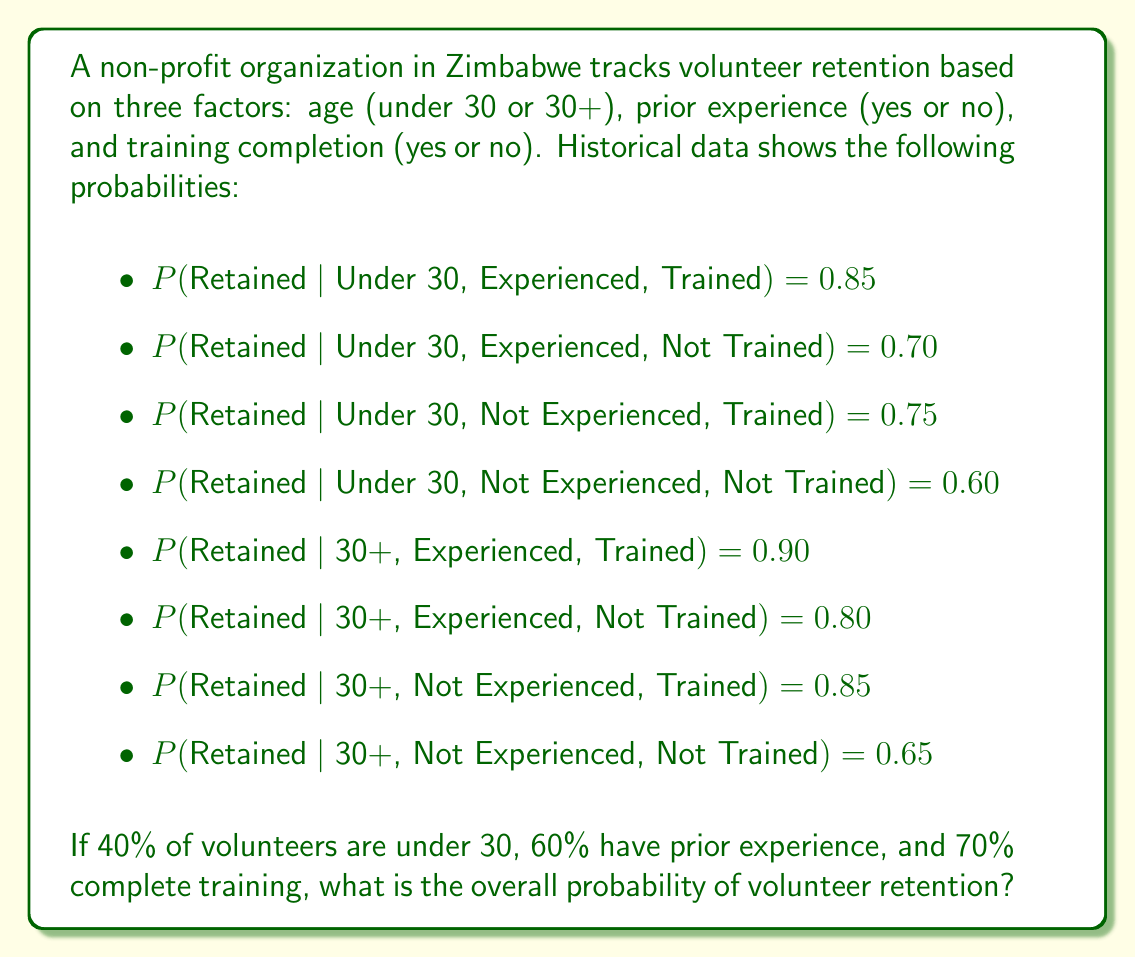Show me your answer to this math problem. To solve this problem, we'll use the law of total probability. We need to consider all possible combinations of the three factors and their respective probabilities.

Let's define events:
A: Under 30, B: Experienced, C: Trained

Step 1: List all possible combinations and their probabilities
P(A) = 0.40, P(Not A) = 0.60
P(B) = 0.60, P(Not B) = 0.40
P(C) = 0.70, P(Not C) = 0.30

Step 2: Calculate the probability of each combination
P(A,B,C) = 0.40 * 0.60 * 0.70 = 0.168
P(A,B,Not C) = 0.40 * 0.60 * 0.30 = 0.072
P(A,Not B,C) = 0.40 * 0.40 * 0.70 = 0.112
P(A,Not B,Not C) = 0.40 * 0.40 * 0.30 = 0.048
P(Not A,B,C) = 0.60 * 0.60 * 0.70 = 0.252
P(Not A,B,Not C) = 0.60 * 0.60 * 0.30 = 0.108
P(Not A,Not B,C) = 0.60 * 0.40 * 0.70 = 0.168
P(Not A,Not B,Not C) = 0.60 * 0.40 * 0.30 = 0.072

Step 3: Apply the law of total probability
$$P(\text{Retained}) = \sum_{i=1}^{8} P(\text{Retained}|\text{Combination}_i) \cdot P(\text{Combination}_i)$$

$$P(\text{Retained}) = 0.85 \cdot 0.168 + 0.70 \cdot 0.072 + 0.75 \cdot 0.112 + 0.60 \cdot 0.048 + $$
$$0.90 \cdot 0.252 + 0.80 \cdot 0.108 + 0.85 \cdot 0.168 + 0.65 \cdot 0.072$$

Step 4: Calculate the final probability
$$P(\text{Retained}) = 0.1428 + 0.0504 + 0.0840 + 0.0288 + 0.2268 + 0.0864 + 0.1428 + 0.0468$$
$$P(\text{Retained}) = 0.8088$$

Therefore, the overall probability of volunteer retention is approximately 0.8088 or 80.88%.
Answer: 0.8088 